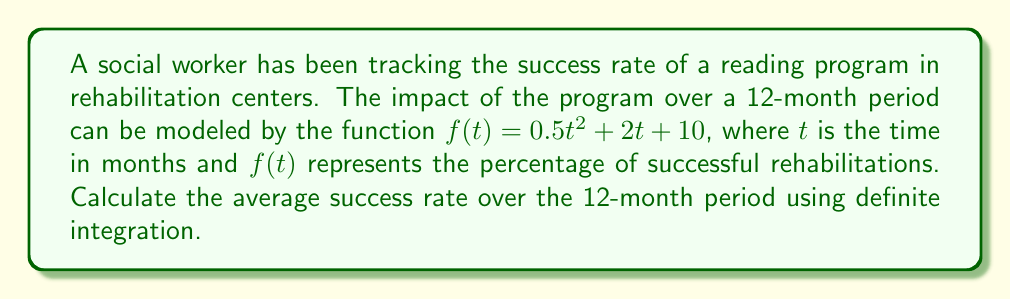Can you answer this question? To solve this problem, we need to follow these steps:

1) The average value of a function $f(t)$ over an interval $[a,b]$ is given by:

   $$ \text{Average} = \frac{1}{b-a} \int_{a}^{b} f(t) dt $$

2) In our case, $a=0$, $b=12$, and $f(t) = 0.5t^2 + 2t + 10$

3) Let's set up the integral:

   $$ \text{Average} = \frac{1}{12-0} \int_{0}^{12} (0.5t^2 + 2t + 10) dt $$

4) Simplify:

   $$ \text{Average} = \frac{1}{12} \int_{0}^{12} (0.5t^2 + 2t + 10) dt $$

5) Integrate:

   $$ \text{Average} = \frac{1}{12} \left[ \frac{1}{3}(0.5t^3) + t^2 + 10t \right]_{0}^{12} $$

6) Evaluate the integral:

   $$ \text{Average} = \frac{1}{12} \left[ (\frac{1}{3}(0.5(12^3)) + 12^2 + 10(12)) - (0 + 0 + 0) \right] $$

7) Simplify:

   $$ \text{Average} = \frac{1}{12} \left[ 288 + 144 + 120 \right] = \frac{552}{12} = 46 $$

Therefore, the average success rate over the 12-month period is 46%.
Answer: 46% 